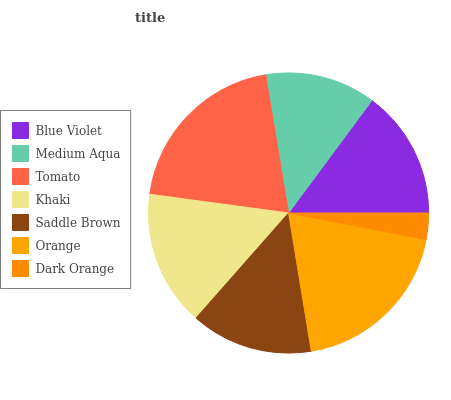Is Dark Orange the minimum?
Answer yes or no. Yes. Is Tomato the maximum?
Answer yes or no. Yes. Is Medium Aqua the minimum?
Answer yes or no. No. Is Medium Aqua the maximum?
Answer yes or no. No. Is Blue Violet greater than Medium Aqua?
Answer yes or no. Yes. Is Medium Aqua less than Blue Violet?
Answer yes or no. Yes. Is Medium Aqua greater than Blue Violet?
Answer yes or no. No. Is Blue Violet less than Medium Aqua?
Answer yes or no. No. Is Blue Violet the high median?
Answer yes or no. Yes. Is Blue Violet the low median?
Answer yes or no. Yes. Is Saddle Brown the high median?
Answer yes or no. No. Is Orange the low median?
Answer yes or no. No. 